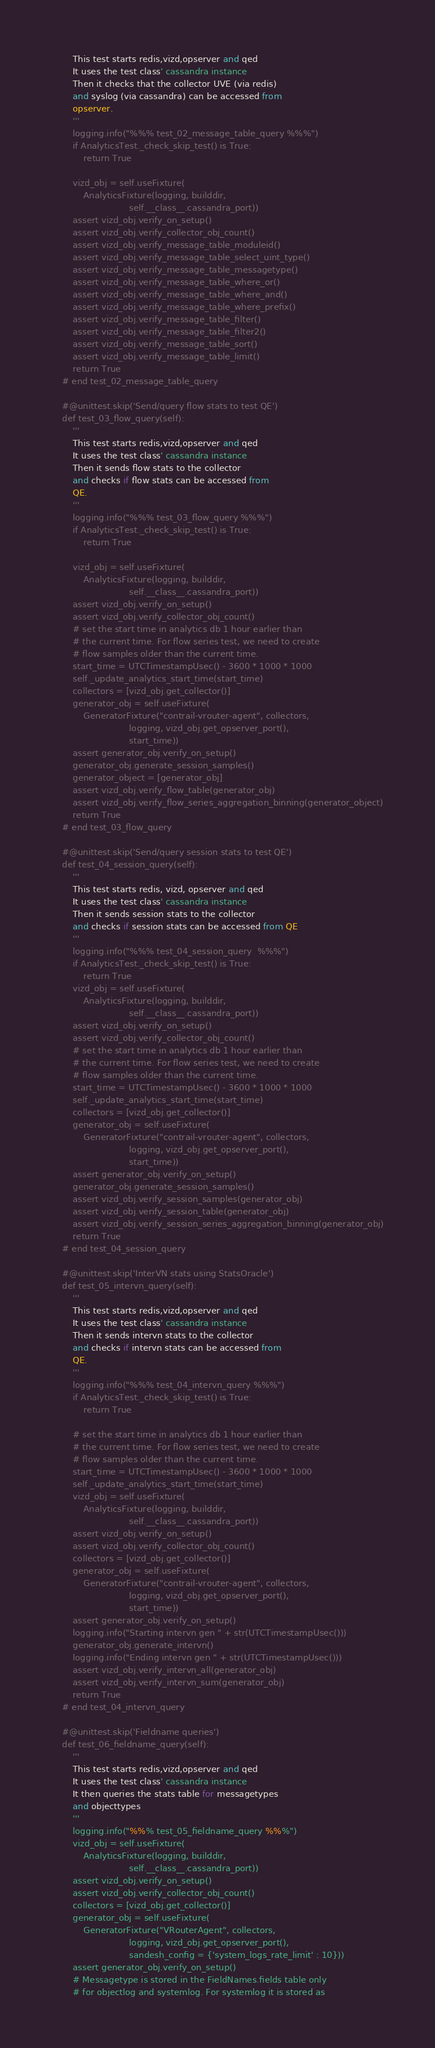<code> <loc_0><loc_0><loc_500><loc_500><_Python_>        This test starts redis,vizd,opserver and qed
        It uses the test class' cassandra instance
        Then it checks that the collector UVE (via redis)
        and syslog (via cassandra) can be accessed from
        opserver.
        '''
        logging.info("%%% test_02_message_table_query %%%")
        if AnalyticsTest._check_skip_test() is True:
            return True

        vizd_obj = self.useFixture(
            AnalyticsFixture(logging, builddir,
                             self.__class__.cassandra_port))
        assert vizd_obj.verify_on_setup()
        assert vizd_obj.verify_collector_obj_count()
        assert vizd_obj.verify_message_table_moduleid()
        assert vizd_obj.verify_message_table_select_uint_type()
        assert vizd_obj.verify_message_table_messagetype()
        assert vizd_obj.verify_message_table_where_or()
        assert vizd_obj.verify_message_table_where_and()
        assert vizd_obj.verify_message_table_where_prefix()
        assert vizd_obj.verify_message_table_filter()
        assert vizd_obj.verify_message_table_filter2()
        assert vizd_obj.verify_message_table_sort()
        assert vizd_obj.verify_message_table_limit()
        return True
    # end test_02_message_table_query

    #@unittest.skip('Send/query flow stats to test QE')
    def test_03_flow_query(self):
        '''
        This test starts redis,vizd,opserver and qed
        It uses the test class' cassandra instance
        Then it sends flow stats to the collector
        and checks if flow stats can be accessed from
        QE.
        '''
        logging.info("%%% test_03_flow_query %%%")
        if AnalyticsTest._check_skip_test() is True:
            return True

        vizd_obj = self.useFixture(
            AnalyticsFixture(logging, builddir,
                             self.__class__.cassandra_port))
        assert vizd_obj.verify_on_setup()
        assert vizd_obj.verify_collector_obj_count()
        # set the start time in analytics db 1 hour earlier than
        # the current time. For flow series test, we need to create
        # flow samples older than the current time.
        start_time = UTCTimestampUsec() - 3600 * 1000 * 1000
        self._update_analytics_start_time(start_time)
        collectors = [vizd_obj.get_collector()]
        generator_obj = self.useFixture(
            GeneratorFixture("contrail-vrouter-agent", collectors,
                             logging, vizd_obj.get_opserver_port(),
                             start_time))
        assert generator_obj.verify_on_setup()
        generator_obj.generate_session_samples()
        generator_object = [generator_obj]
        assert vizd_obj.verify_flow_table(generator_obj)
        assert vizd_obj.verify_flow_series_aggregation_binning(generator_object)
        return True
    # end test_03_flow_query

    #@unittest.skip('Send/query session stats to test QE')
    def test_04_session_query(self):
        '''
        This test starts redis, vizd, opserver and qed
        It uses the test class' cassandra instance
        Then it sends session stats to the collector
        and checks if session stats can be accessed from QE
        '''
        logging.info("%%% test_04_session_query  %%%")
        if AnalyticsTest._check_skip_test() is True:
            return True
        vizd_obj = self.useFixture(
            AnalyticsFixture(logging, builddir,
                             self.__class__.cassandra_port))
        assert vizd_obj.verify_on_setup()
        assert vizd_obj.verify_collector_obj_count()
        # set the start time in analytics db 1 hour earlier than
        # the current time. For flow series test, we need to create
        # flow samples older than the current time.
        start_time = UTCTimestampUsec() - 3600 * 1000 * 1000
        self._update_analytics_start_time(start_time)
        collectors = [vizd_obj.get_collector()]
        generator_obj = self.useFixture(
            GeneratorFixture("contrail-vrouter-agent", collectors,
                             logging, vizd_obj.get_opserver_port(),
                             start_time))
        assert generator_obj.verify_on_setup()
        generator_obj.generate_session_samples()
        assert vizd_obj.verify_session_samples(generator_obj)
        assert vizd_obj.verify_session_table(generator_obj)
        assert vizd_obj.verify_session_series_aggregation_binning(generator_obj)
        return True
    # end test_04_session_query

    #@unittest.skip('InterVN stats using StatsOracle')
    def test_05_intervn_query(self):
        '''
        This test starts redis,vizd,opserver and qed
        It uses the test class' cassandra instance
        Then it sends intervn stats to the collector
        and checks if intervn stats can be accessed from
        QE.
        '''
        logging.info("%%% test_04_intervn_query %%%")
        if AnalyticsTest._check_skip_test() is True:
            return True

        # set the start time in analytics db 1 hour earlier than
        # the current time. For flow series test, we need to create
        # flow samples older than the current time.
        start_time = UTCTimestampUsec() - 3600 * 1000 * 1000
        self._update_analytics_start_time(start_time)
        vizd_obj = self.useFixture(
            AnalyticsFixture(logging, builddir,
                             self.__class__.cassandra_port))
        assert vizd_obj.verify_on_setup()
        assert vizd_obj.verify_collector_obj_count()
        collectors = [vizd_obj.get_collector()]
        generator_obj = self.useFixture(
            GeneratorFixture("contrail-vrouter-agent", collectors,
                             logging, vizd_obj.get_opserver_port(),
                             start_time))
        assert generator_obj.verify_on_setup()
        logging.info("Starting intervn gen " + str(UTCTimestampUsec()))
        generator_obj.generate_intervn()
        logging.info("Ending intervn gen " + str(UTCTimestampUsec()))
        assert vizd_obj.verify_intervn_all(generator_obj)
        assert vizd_obj.verify_intervn_sum(generator_obj)
        return True
    # end test_04_intervn_query

    #@unittest.skip('Fieldname queries')
    def test_06_fieldname_query(self):
        '''
        This test starts redis,vizd,opserver and qed
        It uses the test class' cassandra instance
        It then queries the stats table for messagetypes
        and objecttypes
        '''
        logging.info("%%% test_05_fieldname_query %%%")
        vizd_obj = self.useFixture(
            AnalyticsFixture(logging, builddir,
                             self.__class__.cassandra_port))
        assert vizd_obj.verify_on_setup()
        assert vizd_obj.verify_collector_obj_count()
        collectors = [vizd_obj.get_collector()]
        generator_obj = self.useFixture(
            GeneratorFixture("VRouterAgent", collectors,
                             logging, vizd_obj.get_opserver_port(),
                             sandesh_config = {'system_logs_rate_limit' : 10}))
        assert generator_obj.verify_on_setup()
        # Messagetype is stored in the FieldNames.fields table only
        # for objectlog and systemlog. For systemlog it is stored as</code> 